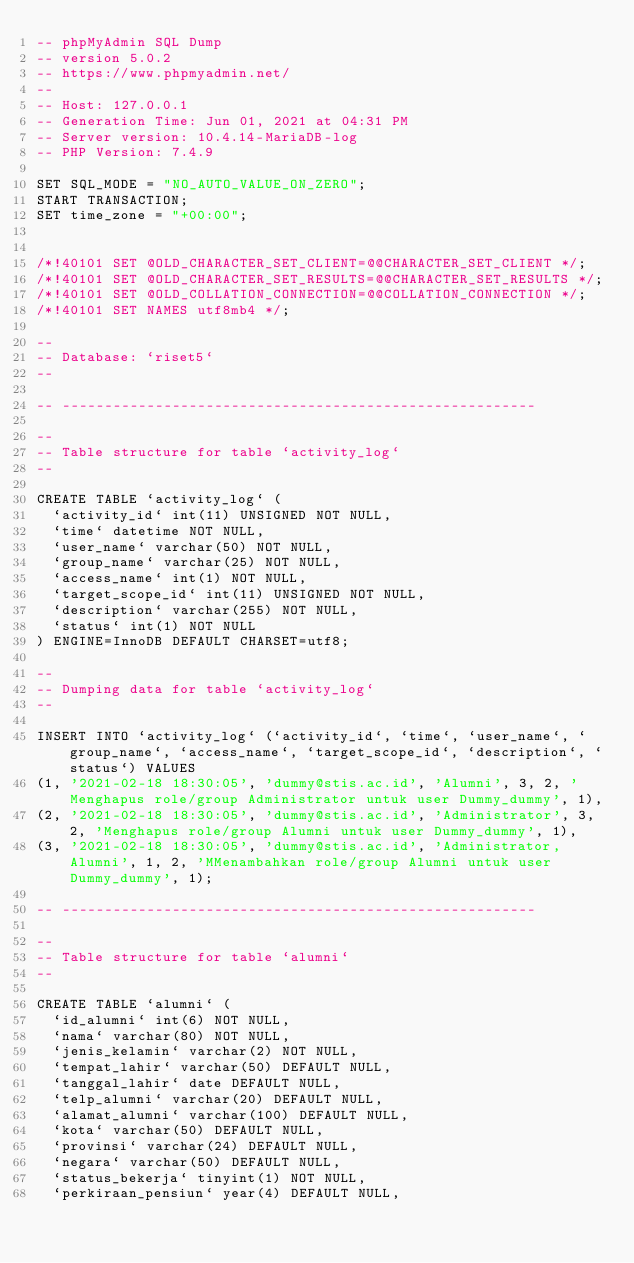<code> <loc_0><loc_0><loc_500><loc_500><_SQL_>-- phpMyAdmin SQL Dump
-- version 5.0.2
-- https://www.phpmyadmin.net/
--
-- Host: 127.0.0.1
-- Generation Time: Jun 01, 2021 at 04:31 PM
-- Server version: 10.4.14-MariaDB-log
-- PHP Version: 7.4.9

SET SQL_MODE = "NO_AUTO_VALUE_ON_ZERO";
START TRANSACTION;
SET time_zone = "+00:00";


/*!40101 SET @OLD_CHARACTER_SET_CLIENT=@@CHARACTER_SET_CLIENT */;
/*!40101 SET @OLD_CHARACTER_SET_RESULTS=@@CHARACTER_SET_RESULTS */;
/*!40101 SET @OLD_COLLATION_CONNECTION=@@COLLATION_CONNECTION */;
/*!40101 SET NAMES utf8mb4 */;

--
-- Database: `riset5`
--

-- --------------------------------------------------------

--
-- Table structure for table `activity_log`
--

CREATE TABLE `activity_log` (
  `activity_id` int(11) UNSIGNED NOT NULL,
  `time` datetime NOT NULL,
  `user_name` varchar(50) NOT NULL,
  `group_name` varchar(25) NOT NULL,
  `access_name` int(1) NOT NULL,
  `target_scope_id` int(11) UNSIGNED NOT NULL,
  `description` varchar(255) NOT NULL,
  `status` int(1) NOT NULL
) ENGINE=InnoDB DEFAULT CHARSET=utf8;

--
-- Dumping data for table `activity_log`
--

INSERT INTO `activity_log` (`activity_id`, `time`, `user_name`, `group_name`, `access_name`, `target_scope_id`, `description`, `status`) VALUES
(1, '2021-02-18 18:30:05', 'dummy@stis.ac.id', 'Alumni', 3, 2, 'Menghapus role/group Administrator untuk user Dummy_dummy', 1),
(2, '2021-02-18 18:30:05', 'dummy@stis.ac.id', 'Administrator', 3, 2, 'Menghapus role/group Alumni untuk user Dummy_dummy', 1),
(3, '2021-02-18 18:30:05', 'dummy@stis.ac.id', 'Administrator,Alumni', 1, 2, 'MMenambahkan role/group Alumni untuk user Dummy_dummy', 1);

-- --------------------------------------------------------

--
-- Table structure for table `alumni`
--

CREATE TABLE `alumni` (
  `id_alumni` int(6) NOT NULL,
  `nama` varchar(80) NOT NULL,
  `jenis_kelamin` varchar(2) NOT NULL,
  `tempat_lahir` varchar(50) DEFAULT NULL,
  `tanggal_lahir` date DEFAULT NULL,
  `telp_alumni` varchar(20) DEFAULT NULL,
  `alamat_alumni` varchar(100) DEFAULT NULL,
  `kota` varchar(50) DEFAULT NULL,
  `provinsi` varchar(24) DEFAULT NULL,
  `negara` varchar(50) DEFAULT NULL,
  `status_bekerja` tinyint(1) NOT NULL,
  `perkiraan_pensiun` year(4) DEFAULT NULL,</code> 